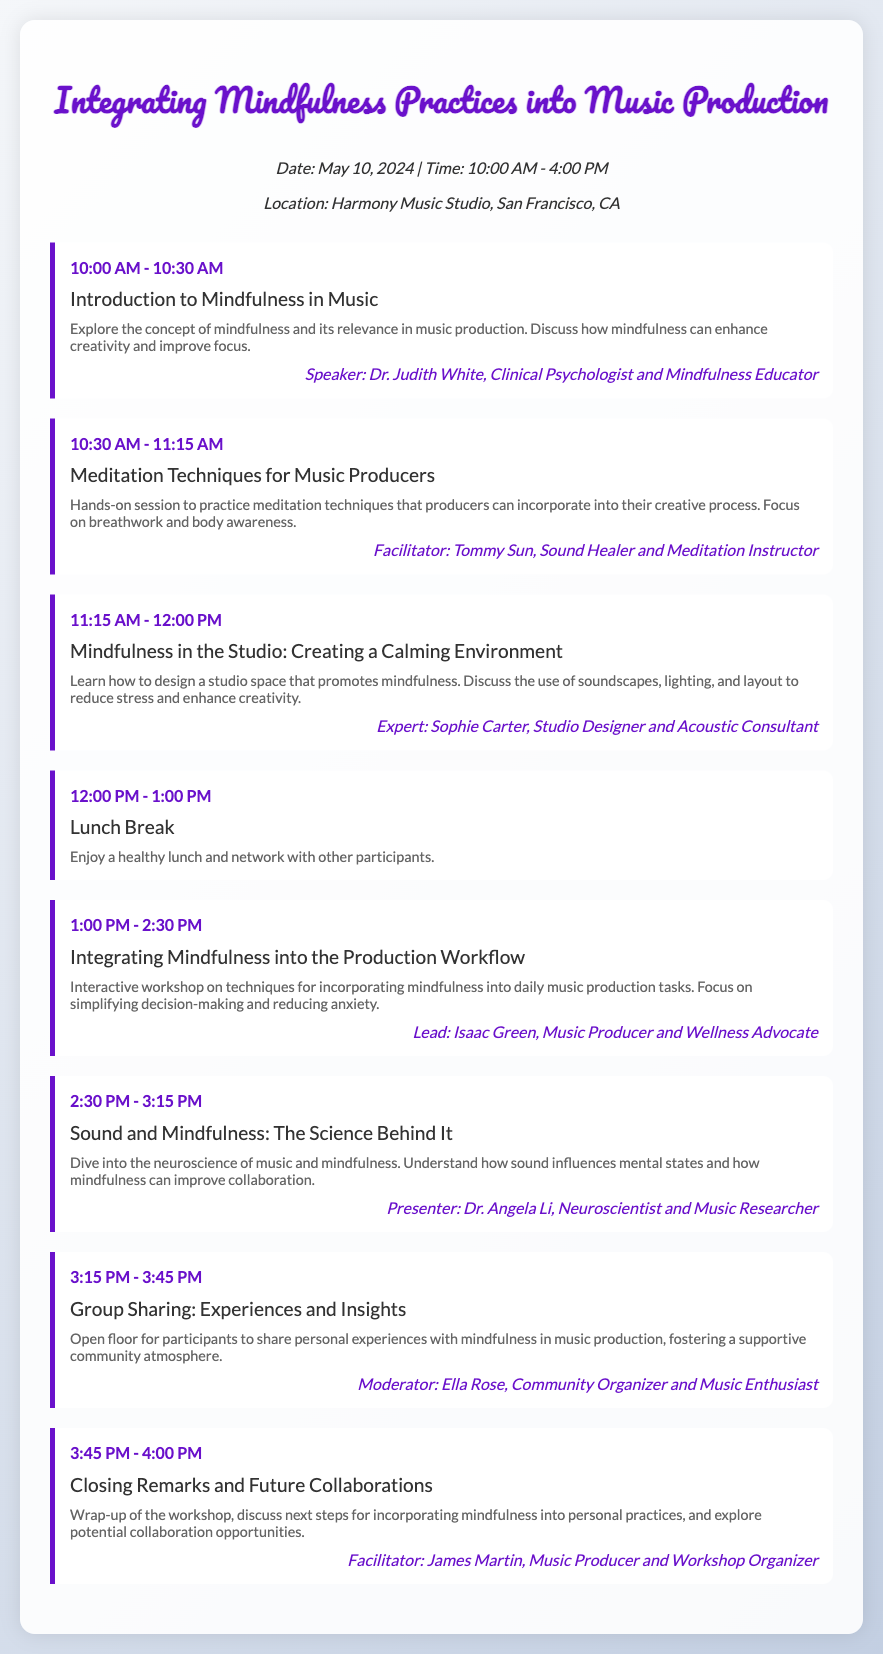What is the date of the workshop? The date of the workshop is explicitly mentioned at the beginning of the document.
Answer: May 10, 2024 Who is the speaker for the introduction session? The speaker is specified in the agenda item for the introduction to mindfulness.
Answer: Dr. Judith White What time does the lunch break start? This information is listed under the lunch break agenda item.
Answer: 12:00 PM What is the title of the session after the lunch break? The title is provided in the agenda sequence following the lunch break.
Answer: Integrating Mindfulness into the Production Workflow Who moderates the group sharing session? The moderator's name is mentioned in the agenda item describing the group sharing.
Answer: Ella Rose What is the focus of the session led by Isaac Green? The emphasis of Isaac Green's session is stated in its description section.
Answer: Reducing anxiety How long is the workshop scheduled to last? The total duration can be calculated from the start and end times of the workshop.
Answer: 6 hours What is the location of the workshop? The location is indicated at the beginning of the document.
Answer: Harmony Music Studio, San Francisco, CA 